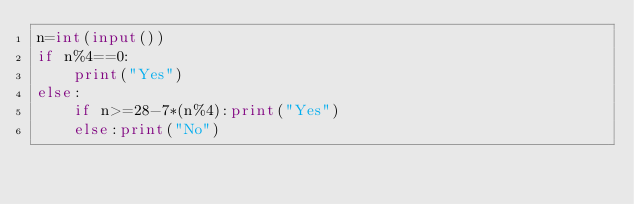Convert code to text. <code><loc_0><loc_0><loc_500><loc_500><_Python_>n=int(input())
if n%4==0:
    print("Yes")
else:
    if n>=28-7*(n%4):print("Yes")
    else:print("No")</code> 